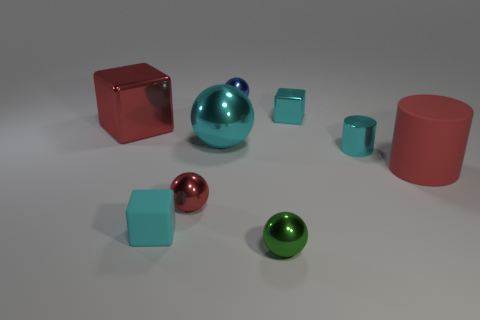Subtract all cyan metal spheres. How many spheres are left? 3 Add 1 big cyan objects. How many objects exist? 10 Subtract all gray spheres. How many cyan blocks are left? 2 Subtract all cyan blocks. How many blocks are left? 1 Subtract all cylinders. How many objects are left? 7 Add 2 tiny cyan metal cylinders. How many tiny cyan metal cylinders exist? 3 Subtract 1 blue balls. How many objects are left? 8 Subtract 1 cylinders. How many cylinders are left? 1 Subtract all yellow blocks. Subtract all green spheres. How many blocks are left? 3 Subtract all matte things. Subtract all matte objects. How many objects are left? 5 